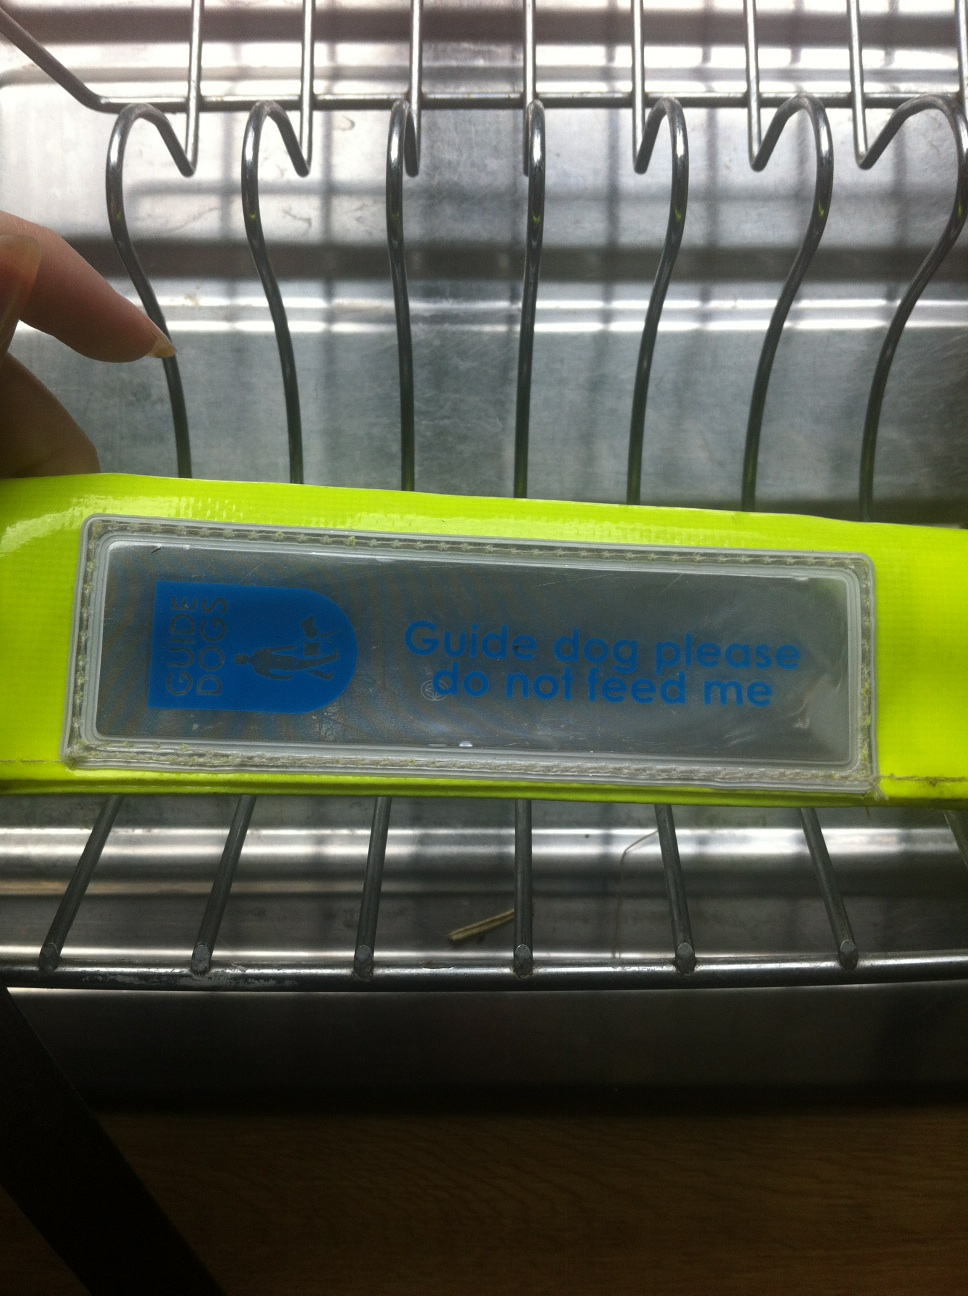Is there a reason the sign's text is so large and clear? Yes, the sign's large and clear text is intentional to make it easily readable by a passing person. Visibility is important, as it must quickly convey the message not to feed the guide dog to anybody who might interact with the dog. This prevents distractions and feeding which could compromise the dog's training and performance. Why is it important not to feed a guide dog? Feeding a guide dog can disrupt its strict diet and schedule, which can cause health issues and affect its ability to work. It can also lead to unwanted begging behaviors or distract the dog from its duties, potentially putting the handler in danger. It's part of respecting the working relationship and boundaries between a service animal and their handler. 